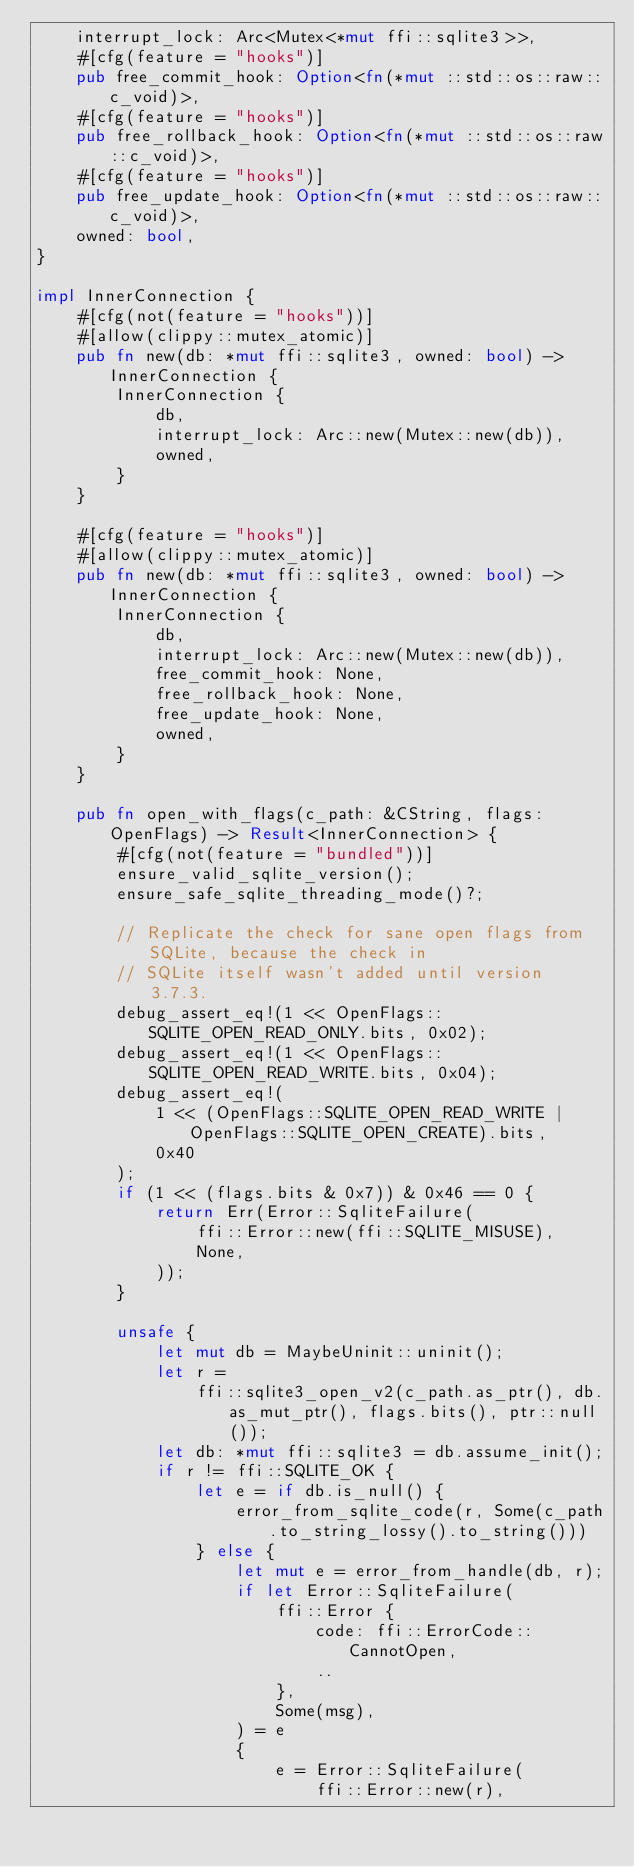<code> <loc_0><loc_0><loc_500><loc_500><_Rust_>    interrupt_lock: Arc<Mutex<*mut ffi::sqlite3>>,
    #[cfg(feature = "hooks")]
    pub free_commit_hook: Option<fn(*mut ::std::os::raw::c_void)>,
    #[cfg(feature = "hooks")]
    pub free_rollback_hook: Option<fn(*mut ::std::os::raw::c_void)>,
    #[cfg(feature = "hooks")]
    pub free_update_hook: Option<fn(*mut ::std::os::raw::c_void)>,
    owned: bool,
}

impl InnerConnection {
    #[cfg(not(feature = "hooks"))]
    #[allow(clippy::mutex_atomic)]
    pub fn new(db: *mut ffi::sqlite3, owned: bool) -> InnerConnection {
        InnerConnection {
            db,
            interrupt_lock: Arc::new(Mutex::new(db)),
            owned,
        }
    }

    #[cfg(feature = "hooks")]
    #[allow(clippy::mutex_atomic)]
    pub fn new(db: *mut ffi::sqlite3, owned: bool) -> InnerConnection {
        InnerConnection {
            db,
            interrupt_lock: Arc::new(Mutex::new(db)),
            free_commit_hook: None,
            free_rollback_hook: None,
            free_update_hook: None,
            owned,
        }
    }

    pub fn open_with_flags(c_path: &CString, flags: OpenFlags) -> Result<InnerConnection> {
        #[cfg(not(feature = "bundled"))]
        ensure_valid_sqlite_version();
        ensure_safe_sqlite_threading_mode()?;

        // Replicate the check for sane open flags from SQLite, because the check in
        // SQLite itself wasn't added until version 3.7.3.
        debug_assert_eq!(1 << OpenFlags::SQLITE_OPEN_READ_ONLY.bits, 0x02);
        debug_assert_eq!(1 << OpenFlags::SQLITE_OPEN_READ_WRITE.bits, 0x04);
        debug_assert_eq!(
            1 << (OpenFlags::SQLITE_OPEN_READ_WRITE | OpenFlags::SQLITE_OPEN_CREATE).bits,
            0x40
        );
        if (1 << (flags.bits & 0x7)) & 0x46 == 0 {
            return Err(Error::SqliteFailure(
                ffi::Error::new(ffi::SQLITE_MISUSE),
                None,
            ));
        }

        unsafe {
            let mut db = MaybeUninit::uninit();
            let r =
                ffi::sqlite3_open_v2(c_path.as_ptr(), db.as_mut_ptr(), flags.bits(), ptr::null());
            let db: *mut ffi::sqlite3 = db.assume_init();
            if r != ffi::SQLITE_OK {
                let e = if db.is_null() {
                    error_from_sqlite_code(r, Some(c_path.to_string_lossy().to_string()))
                } else {
                    let mut e = error_from_handle(db, r);
                    if let Error::SqliteFailure(
                        ffi::Error {
                            code: ffi::ErrorCode::CannotOpen,
                            ..
                        },
                        Some(msg),
                    ) = e
                    {
                        e = Error::SqliteFailure(
                            ffi::Error::new(r),</code> 